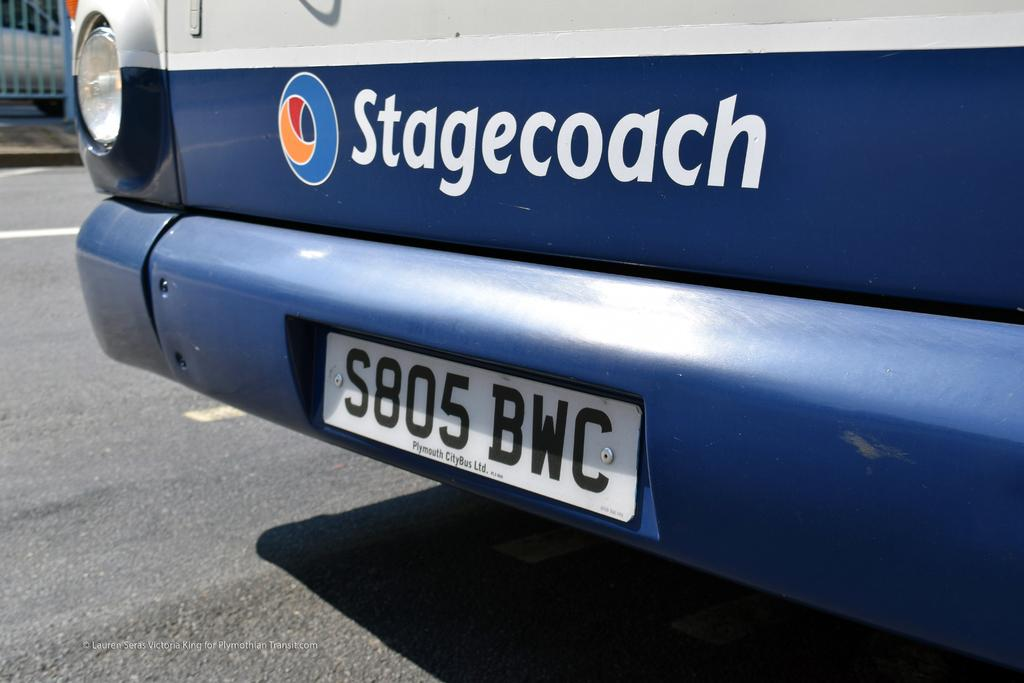<image>
Relay a brief, clear account of the picture shown. a license plate with the letters BWC on it 